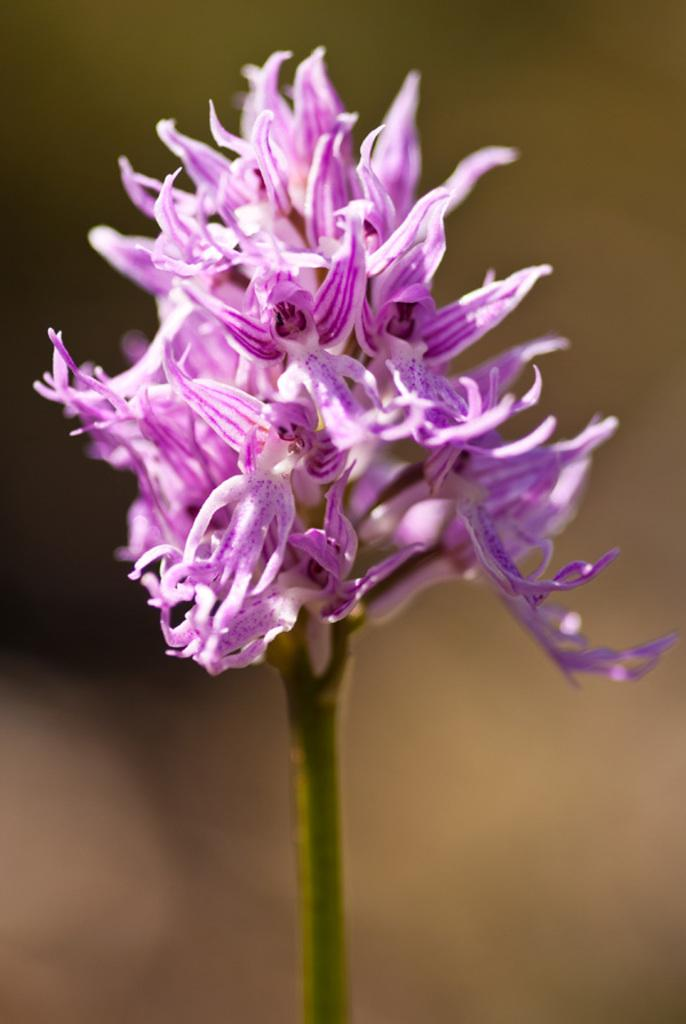What is the main subject of the image? The main subject of the image is a flower. Can you describe the flower in more detail? The flower is attached to a stem. What can be observed about the background of the image? The background of the image is blurred. How many lead toys are visible in the image? There are no lead toys present in the image. What type of ducks can be seen swimming in the background of the image? There are no ducks present in the image, and the background is blurred. 